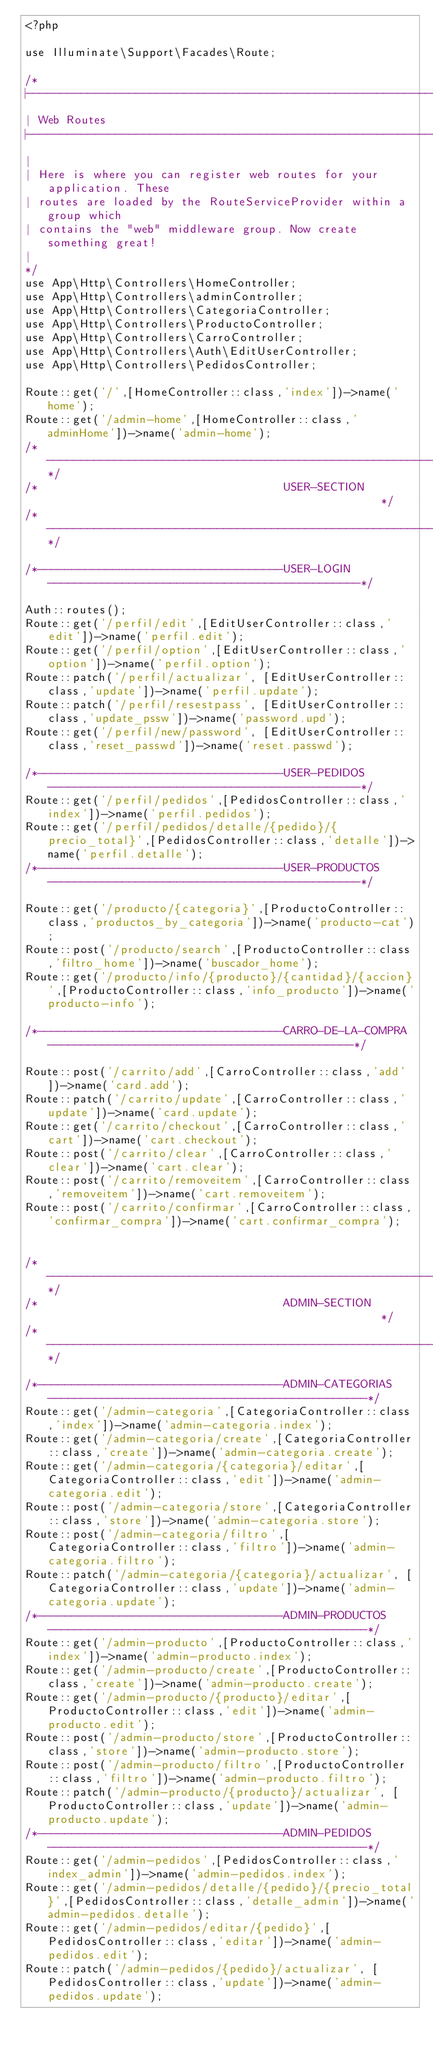<code> <loc_0><loc_0><loc_500><loc_500><_PHP_><?php

use Illuminate\Support\Facades\Route;

/*
|--------------------------------------------------------------------------
| Web Routes
|--------------------------------------------------------------------------
|
| Here is where you can register web routes for your application. These
| routes are loaded by the RouteServiceProvider within a group which
| contains the "web" middleware group. Now create something great!
|
*/
use App\Http\Controllers\HomeController;
use App\Http\Controllers\adminController;
use App\Http\Controllers\CategoriaController;
use App\Http\Controllers\ProductoController;
use App\Http\Controllers\CarroController;
use App\Http\Controllers\Auth\EditUserController;
use App\Http\Controllers\PedidosController;

Route::get('/',[HomeController::class,'index'])->name('home');
Route::get('/admin-home',[HomeController::class,'adminHome'])->name('admin-home');
/*---------------------------------------------------------------------------------------------------*/
/*                                    USER-SECTION                                                  */
/*---------------------------------------------------------------------------------------------------*/

/*------------------------------------USER-LOGIN----------------------------------------------*/

Auth::routes();
Route::get('/perfil/edit',[EditUserController::class,'edit'])->name('perfil.edit');
Route::get('/perfil/option',[EditUserController::class,'option'])->name('perfil.option');
Route::patch('/perfil/actualizar', [EditUserController::class,'update'])->name('perfil.update'); 
Route::patch('/perfil/resestpass', [EditUserController::class,'update_pssw'])->name('password.upd');
Route::get('/perfil/new/password', [EditUserController::class,'reset_passwd'])->name('reset.passwd');

/*------------------------------------USER-PEDIDOS----------------------------------------------*/
Route::get('/perfil/pedidos',[PedidosController::class,'index'])->name('perfil.pedidos');
Route::get('/perfil/pedidos/detalle/{pedido}/{precio_total}',[PedidosController::class,'detalle'])->name('perfil.detalle');
/*------------------------------------USER-PRODUCTOS----------------------------------------------*/

Route::get('/producto/{categoria}',[ProductoController::class,'productos_by_categoria'])->name('producto-cat');
Route::post('/producto/search',[ProductoController::class,'filtro_home'])->name('buscador_home');
Route::get('/producto/info/{producto}/{cantidad}/{accion}',[ProductoController::class,'info_producto'])->name('producto-info');

/*------------------------------------CARRO-DE-LA-COMPRA---------------------------------------------*/

Route::post('/carrito/add',[CarroController::class,'add'])->name('card.add');
Route::patch('/carrito/update',[CarroController::class,'update'])->name('card.update');
Route::get('/carrito/checkout',[CarroController::class,'cart'])->name('cart.checkout');
Route::post('/carrito/clear',[CarroController::class,'clear'])->name('cart.clear');
Route::post('/carrito/removeitem',[CarroController::class,'removeitem'])->name('cart.removeitem');
Route::post('/carrito/confirmar',[CarroController::class,'confirmar_compra'])->name('cart.confirmar_compra');


/*---------------------------------------------------------------------------------------------------*/
/*                                    ADMIN-SECTION                                                  */
/*---------------------------------------------------------------------------------------------------*/

/*------------------------------------ADMIN-CATEGORIAS-----------------------------------------------*/
Route::get('/admin-categoria',[CategoriaController::class,'index'])->name('admin-categoria.index');
Route::get('/admin-categoria/create',[CategoriaController::class,'create'])->name('admin-categoria.create');
Route::get('/admin-categoria/{categoria}/editar',[CategoriaController::class,'edit'])->name('admin-categoria.edit');
Route::post('/admin-categoria/store',[CategoriaController::class,'store'])->name('admin-categoria.store');
Route::post('/admin-categoria/filtro',[CategoriaController::class,'filtro'])->name('admin-categoria.filtro');
Route::patch('/admin-categoria/{categoria}/actualizar', [CategoriaController::class,'update'])->name('admin-categoria.update');
/*------------------------------------ADMIN-PRODUCTOS-----------------------------------------------*/
Route::get('/admin-producto',[ProductoController::class,'index'])->name('admin-producto.index');
Route::get('/admin-producto/create',[ProductoController::class,'create'])->name('admin-producto.create');
Route::get('/admin-producto/{producto}/editar',[ProductoController::class,'edit'])->name('admin-producto.edit');
Route::post('/admin-producto/store',[ProductoController::class,'store'])->name('admin-producto.store');
Route::post('/admin-producto/filtro',[ProductoController::class,'filtro'])->name('admin-producto.filtro');
Route::patch('/admin-producto/{producto}/actualizar', [ProductoController::class,'update'])->name('admin-producto.update');
/*------------------------------------ADMIN-PEDIDOS-----------------------------------------------*/
Route::get('/admin-pedidos',[PedidosController::class,'index_admin'])->name('admin-pedidos.index');
Route::get('/admin-pedidos/detalle/{pedido}/{precio_total}',[PedidosController::class,'detalle_admin'])->name('admin-pedidos.detalle');
Route::get('/admin-pedidos/editar/{pedido}',[PedidosController::class,'editar'])->name('admin-pedidos.edit');
Route::patch('/admin-pedidos/{pedido}/actualizar', [PedidosController::class,'update'])->name('admin-pedidos.update');

</code> 